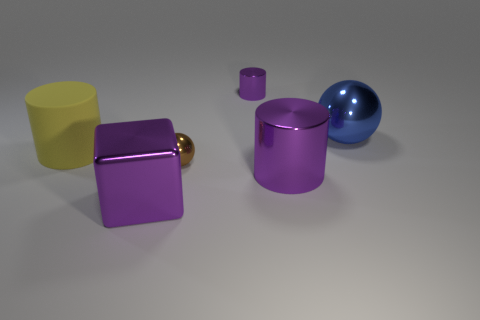Add 3 tiny objects. How many objects exist? 9 Subtract all cubes. How many objects are left? 5 Subtract 0 red balls. How many objects are left? 6 Subtract all small red cylinders. Subtract all big purple cubes. How many objects are left? 5 Add 3 large purple metal cylinders. How many large purple metal cylinders are left? 4 Add 6 yellow cylinders. How many yellow cylinders exist? 7 